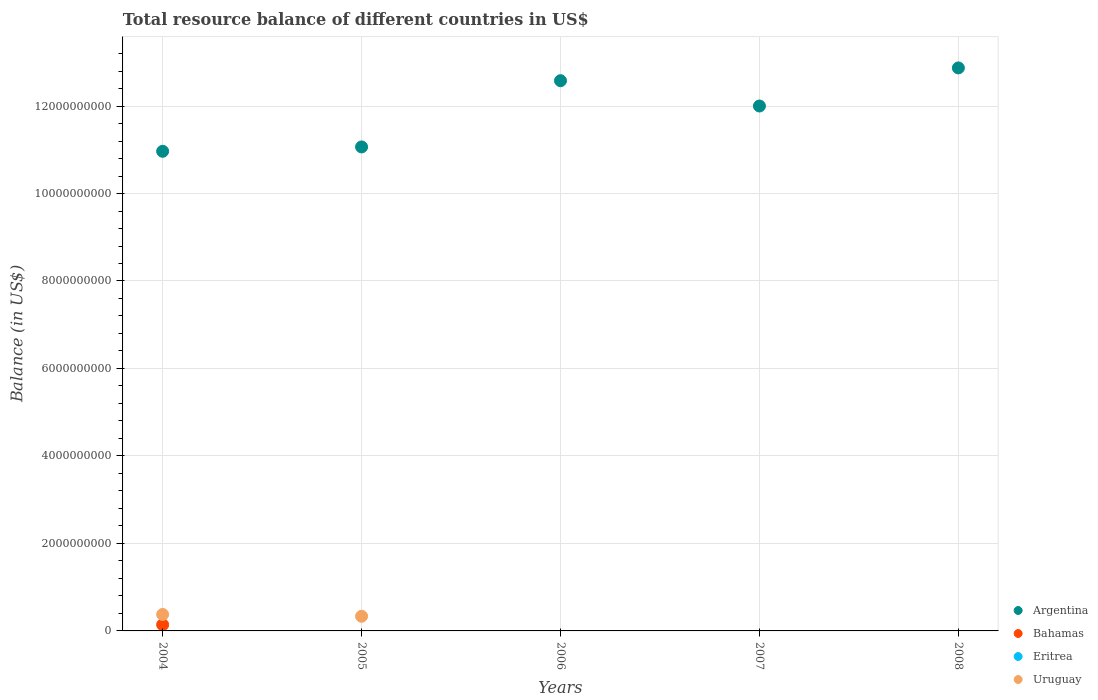Is the number of dotlines equal to the number of legend labels?
Your answer should be compact. No. What is the total resource balance in Bahamas in 2004?
Offer a terse response. 1.42e+08. Across all years, what is the maximum total resource balance in Bahamas?
Ensure brevity in your answer.  1.42e+08. Across all years, what is the minimum total resource balance in Bahamas?
Your answer should be compact. 0. What is the total total resource balance in Uruguay in the graph?
Ensure brevity in your answer.  7.11e+08. What is the difference between the total resource balance in Argentina in 2004 and that in 2006?
Make the answer very short. -1.61e+09. What is the difference between the total resource balance in Eritrea in 2004 and the total resource balance in Uruguay in 2007?
Offer a very short reply. 0. What is the average total resource balance in Bahamas per year?
Give a very brief answer. 2.84e+07. In the year 2004, what is the difference between the total resource balance in Uruguay and total resource balance in Bahamas?
Your response must be concise. 2.34e+08. In how many years, is the total resource balance in Bahamas greater than 11200000000 US$?
Your answer should be very brief. 0. What is the ratio of the total resource balance in Uruguay in 2004 to that in 2005?
Provide a short and direct response. 1.12. What is the difference between the highest and the second highest total resource balance in Argentina?
Keep it short and to the point. 2.92e+08. What is the difference between the highest and the lowest total resource balance in Argentina?
Offer a very short reply. 1.91e+09. In how many years, is the total resource balance in Uruguay greater than the average total resource balance in Uruguay taken over all years?
Your answer should be very brief. 2. Is the sum of the total resource balance in Argentina in 2005 and 2006 greater than the maximum total resource balance in Bahamas across all years?
Provide a short and direct response. Yes. Does the total resource balance in Uruguay monotonically increase over the years?
Make the answer very short. No. Does the graph contain any zero values?
Give a very brief answer. Yes. Does the graph contain grids?
Your answer should be very brief. Yes. Where does the legend appear in the graph?
Offer a terse response. Bottom right. How are the legend labels stacked?
Ensure brevity in your answer.  Vertical. What is the title of the graph?
Your response must be concise. Total resource balance of different countries in US$. What is the label or title of the X-axis?
Provide a short and direct response. Years. What is the label or title of the Y-axis?
Your answer should be very brief. Balance (in US$). What is the Balance (in US$) of Argentina in 2004?
Offer a terse response. 1.10e+1. What is the Balance (in US$) in Bahamas in 2004?
Provide a succinct answer. 1.42e+08. What is the Balance (in US$) in Eritrea in 2004?
Your response must be concise. 0. What is the Balance (in US$) of Uruguay in 2004?
Provide a succinct answer. 3.76e+08. What is the Balance (in US$) of Argentina in 2005?
Your answer should be very brief. 1.11e+1. What is the Balance (in US$) of Bahamas in 2005?
Your response must be concise. 0. What is the Balance (in US$) of Eritrea in 2005?
Keep it short and to the point. 0. What is the Balance (in US$) in Uruguay in 2005?
Your response must be concise. 3.35e+08. What is the Balance (in US$) in Argentina in 2006?
Your response must be concise. 1.26e+1. What is the Balance (in US$) in Argentina in 2007?
Make the answer very short. 1.20e+1. What is the Balance (in US$) of Bahamas in 2007?
Your response must be concise. 0. What is the Balance (in US$) in Eritrea in 2007?
Keep it short and to the point. 0. What is the Balance (in US$) in Argentina in 2008?
Offer a very short reply. 1.29e+1. What is the Balance (in US$) in Uruguay in 2008?
Provide a short and direct response. 0. Across all years, what is the maximum Balance (in US$) of Argentina?
Give a very brief answer. 1.29e+1. Across all years, what is the maximum Balance (in US$) of Bahamas?
Your answer should be very brief. 1.42e+08. Across all years, what is the maximum Balance (in US$) in Uruguay?
Your answer should be compact. 3.76e+08. Across all years, what is the minimum Balance (in US$) in Argentina?
Offer a terse response. 1.10e+1. Across all years, what is the minimum Balance (in US$) of Bahamas?
Offer a very short reply. 0. Across all years, what is the minimum Balance (in US$) in Uruguay?
Give a very brief answer. 0. What is the total Balance (in US$) in Argentina in the graph?
Provide a succinct answer. 5.95e+1. What is the total Balance (in US$) of Bahamas in the graph?
Offer a terse response. 1.42e+08. What is the total Balance (in US$) in Eritrea in the graph?
Give a very brief answer. 0. What is the total Balance (in US$) in Uruguay in the graph?
Your response must be concise. 7.11e+08. What is the difference between the Balance (in US$) of Argentina in 2004 and that in 2005?
Your answer should be very brief. -9.97e+07. What is the difference between the Balance (in US$) in Uruguay in 2004 and that in 2005?
Your answer should be compact. 4.09e+07. What is the difference between the Balance (in US$) in Argentina in 2004 and that in 2006?
Offer a terse response. -1.61e+09. What is the difference between the Balance (in US$) of Argentina in 2004 and that in 2007?
Make the answer very short. -1.04e+09. What is the difference between the Balance (in US$) in Argentina in 2004 and that in 2008?
Give a very brief answer. -1.91e+09. What is the difference between the Balance (in US$) in Argentina in 2005 and that in 2006?
Ensure brevity in your answer.  -1.51e+09. What is the difference between the Balance (in US$) in Argentina in 2005 and that in 2007?
Give a very brief answer. -9.36e+08. What is the difference between the Balance (in US$) in Argentina in 2005 and that in 2008?
Keep it short and to the point. -1.81e+09. What is the difference between the Balance (in US$) of Argentina in 2006 and that in 2007?
Give a very brief answer. 5.79e+08. What is the difference between the Balance (in US$) of Argentina in 2006 and that in 2008?
Give a very brief answer. -2.92e+08. What is the difference between the Balance (in US$) in Argentina in 2007 and that in 2008?
Offer a very short reply. -8.71e+08. What is the difference between the Balance (in US$) of Argentina in 2004 and the Balance (in US$) of Uruguay in 2005?
Offer a terse response. 1.06e+1. What is the difference between the Balance (in US$) in Bahamas in 2004 and the Balance (in US$) in Uruguay in 2005?
Give a very brief answer. -1.93e+08. What is the average Balance (in US$) in Argentina per year?
Give a very brief answer. 1.19e+1. What is the average Balance (in US$) in Bahamas per year?
Offer a very short reply. 2.84e+07. What is the average Balance (in US$) of Eritrea per year?
Offer a very short reply. 0. What is the average Balance (in US$) of Uruguay per year?
Give a very brief answer. 1.42e+08. In the year 2004, what is the difference between the Balance (in US$) of Argentina and Balance (in US$) of Bahamas?
Offer a very short reply. 1.08e+1. In the year 2004, what is the difference between the Balance (in US$) in Argentina and Balance (in US$) in Uruguay?
Provide a short and direct response. 1.06e+1. In the year 2004, what is the difference between the Balance (in US$) in Bahamas and Balance (in US$) in Uruguay?
Offer a terse response. -2.34e+08. In the year 2005, what is the difference between the Balance (in US$) in Argentina and Balance (in US$) in Uruguay?
Offer a terse response. 1.07e+1. What is the ratio of the Balance (in US$) in Argentina in 2004 to that in 2005?
Give a very brief answer. 0.99. What is the ratio of the Balance (in US$) in Uruguay in 2004 to that in 2005?
Provide a succinct answer. 1.12. What is the ratio of the Balance (in US$) in Argentina in 2004 to that in 2006?
Offer a terse response. 0.87. What is the ratio of the Balance (in US$) in Argentina in 2004 to that in 2007?
Give a very brief answer. 0.91. What is the ratio of the Balance (in US$) in Argentina in 2004 to that in 2008?
Your answer should be very brief. 0.85. What is the ratio of the Balance (in US$) of Argentina in 2005 to that in 2006?
Provide a succinct answer. 0.88. What is the ratio of the Balance (in US$) in Argentina in 2005 to that in 2007?
Provide a short and direct response. 0.92. What is the ratio of the Balance (in US$) of Argentina in 2005 to that in 2008?
Make the answer very short. 0.86. What is the ratio of the Balance (in US$) of Argentina in 2006 to that in 2007?
Keep it short and to the point. 1.05. What is the ratio of the Balance (in US$) of Argentina in 2006 to that in 2008?
Your answer should be very brief. 0.98. What is the ratio of the Balance (in US$) of Argentina in 2007 to that in 2008?
Provide a short and direct response. 0.93. What is the difference between the highest and the second highest Balance (in US$) in Argentina?
Offer a very short reply. 2.92e+08. What is the difference between the highest and the lowest Balance (in US$) of Argentina?
Make the answer very short. 1.91e+09. What is the difference between the highest and the lowest Balance (in US$) of Bahamas?
Provide a short and direct response. 1.42e+08. What is the difference between the highest and the lowest Balance (in US$) of Uruguay?
Give a very brief answer. 3.76e+08. 